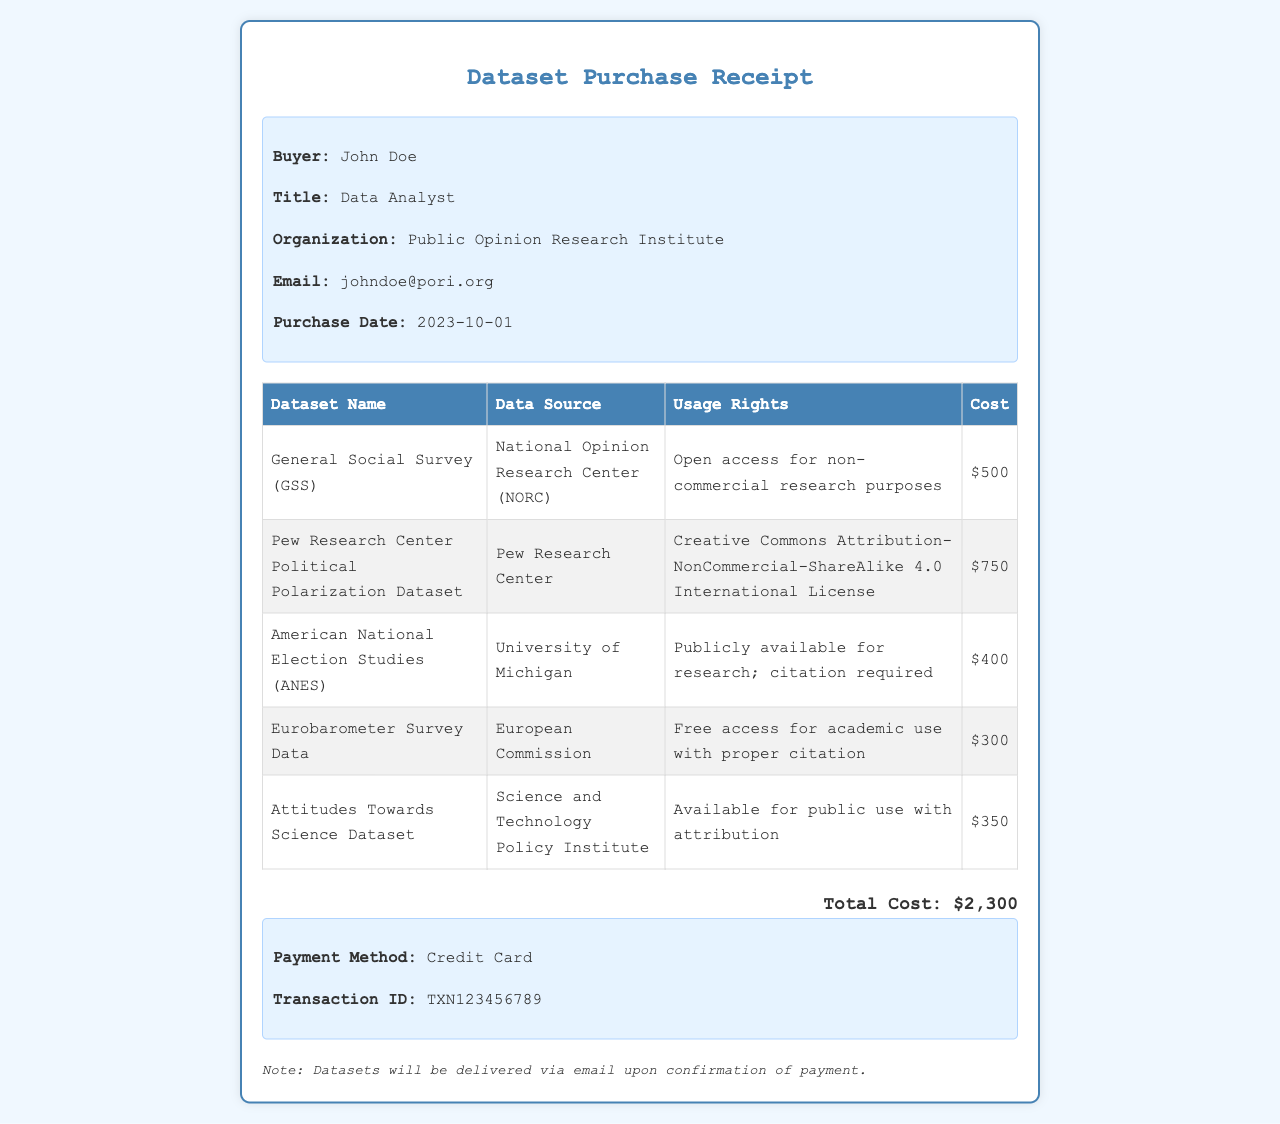What is the buyer's name? The buyer's name is explicitly mentioned in the buyer info section of the receipt.
Answer: John Doe What organization does the buyer belong to? The organization is listed in the buyer info section under "Organization."
Answer: Public Opinion Research Institute What is the total cost of the datasets? The total cost is calculated at the bottom of the document.
Answer: $2,300 How many datasets were purchased? The number of datasets can be counted from the table provided in the document.
Answer: 5 Which dataset is sourced from the National Opinion Research Center? This information can be found under the "Data Source" column in the dataset table.
Answer: General Social Survey (GSS) What type of usage rights does the Pew Research Center Political Polarization Dataset have? The usage rights are specified in the same table in the document.
Answer: Creative Commons Attribution-NonCommercial-ShareAlike 4.0 International License What date was the purchase made? The purchase date is explicitly mentioned in the buyer info section.
Answer: 2023-10-01 What payment method was used? The payment method is detailed in the payment info section of the receipt.
Answer: Credit Card What will happen upon confirmation of payment? This refers to the note at the bottom of the receipt regarding the delivery of datasets.
Answer: Datasets will be delivered via email 